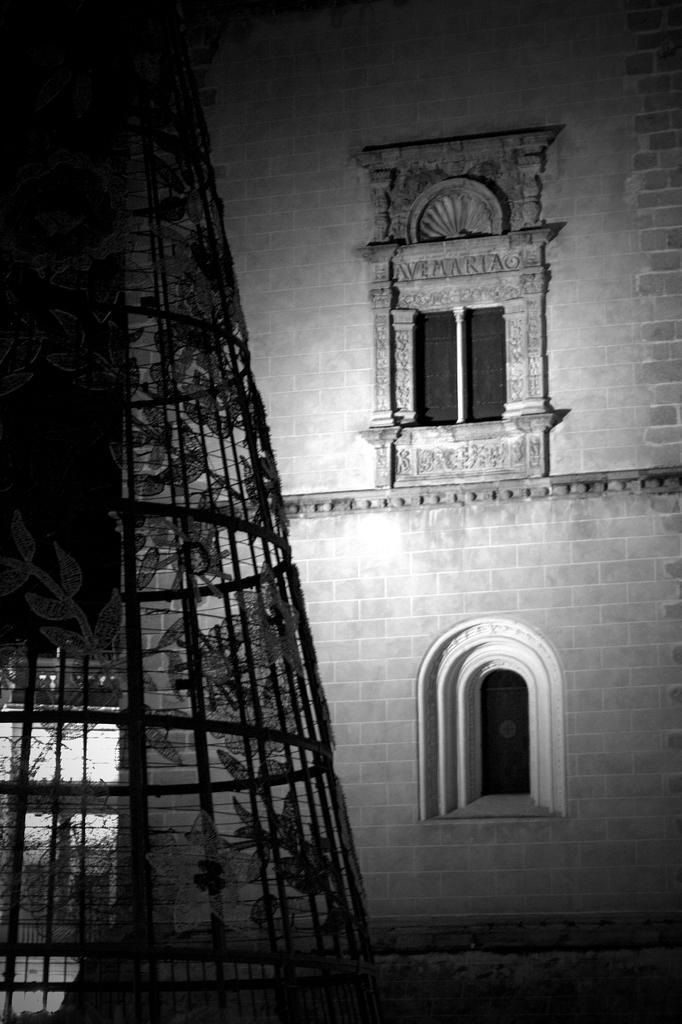Please provide a concise description of this image. There is a building which has 2 windows. 